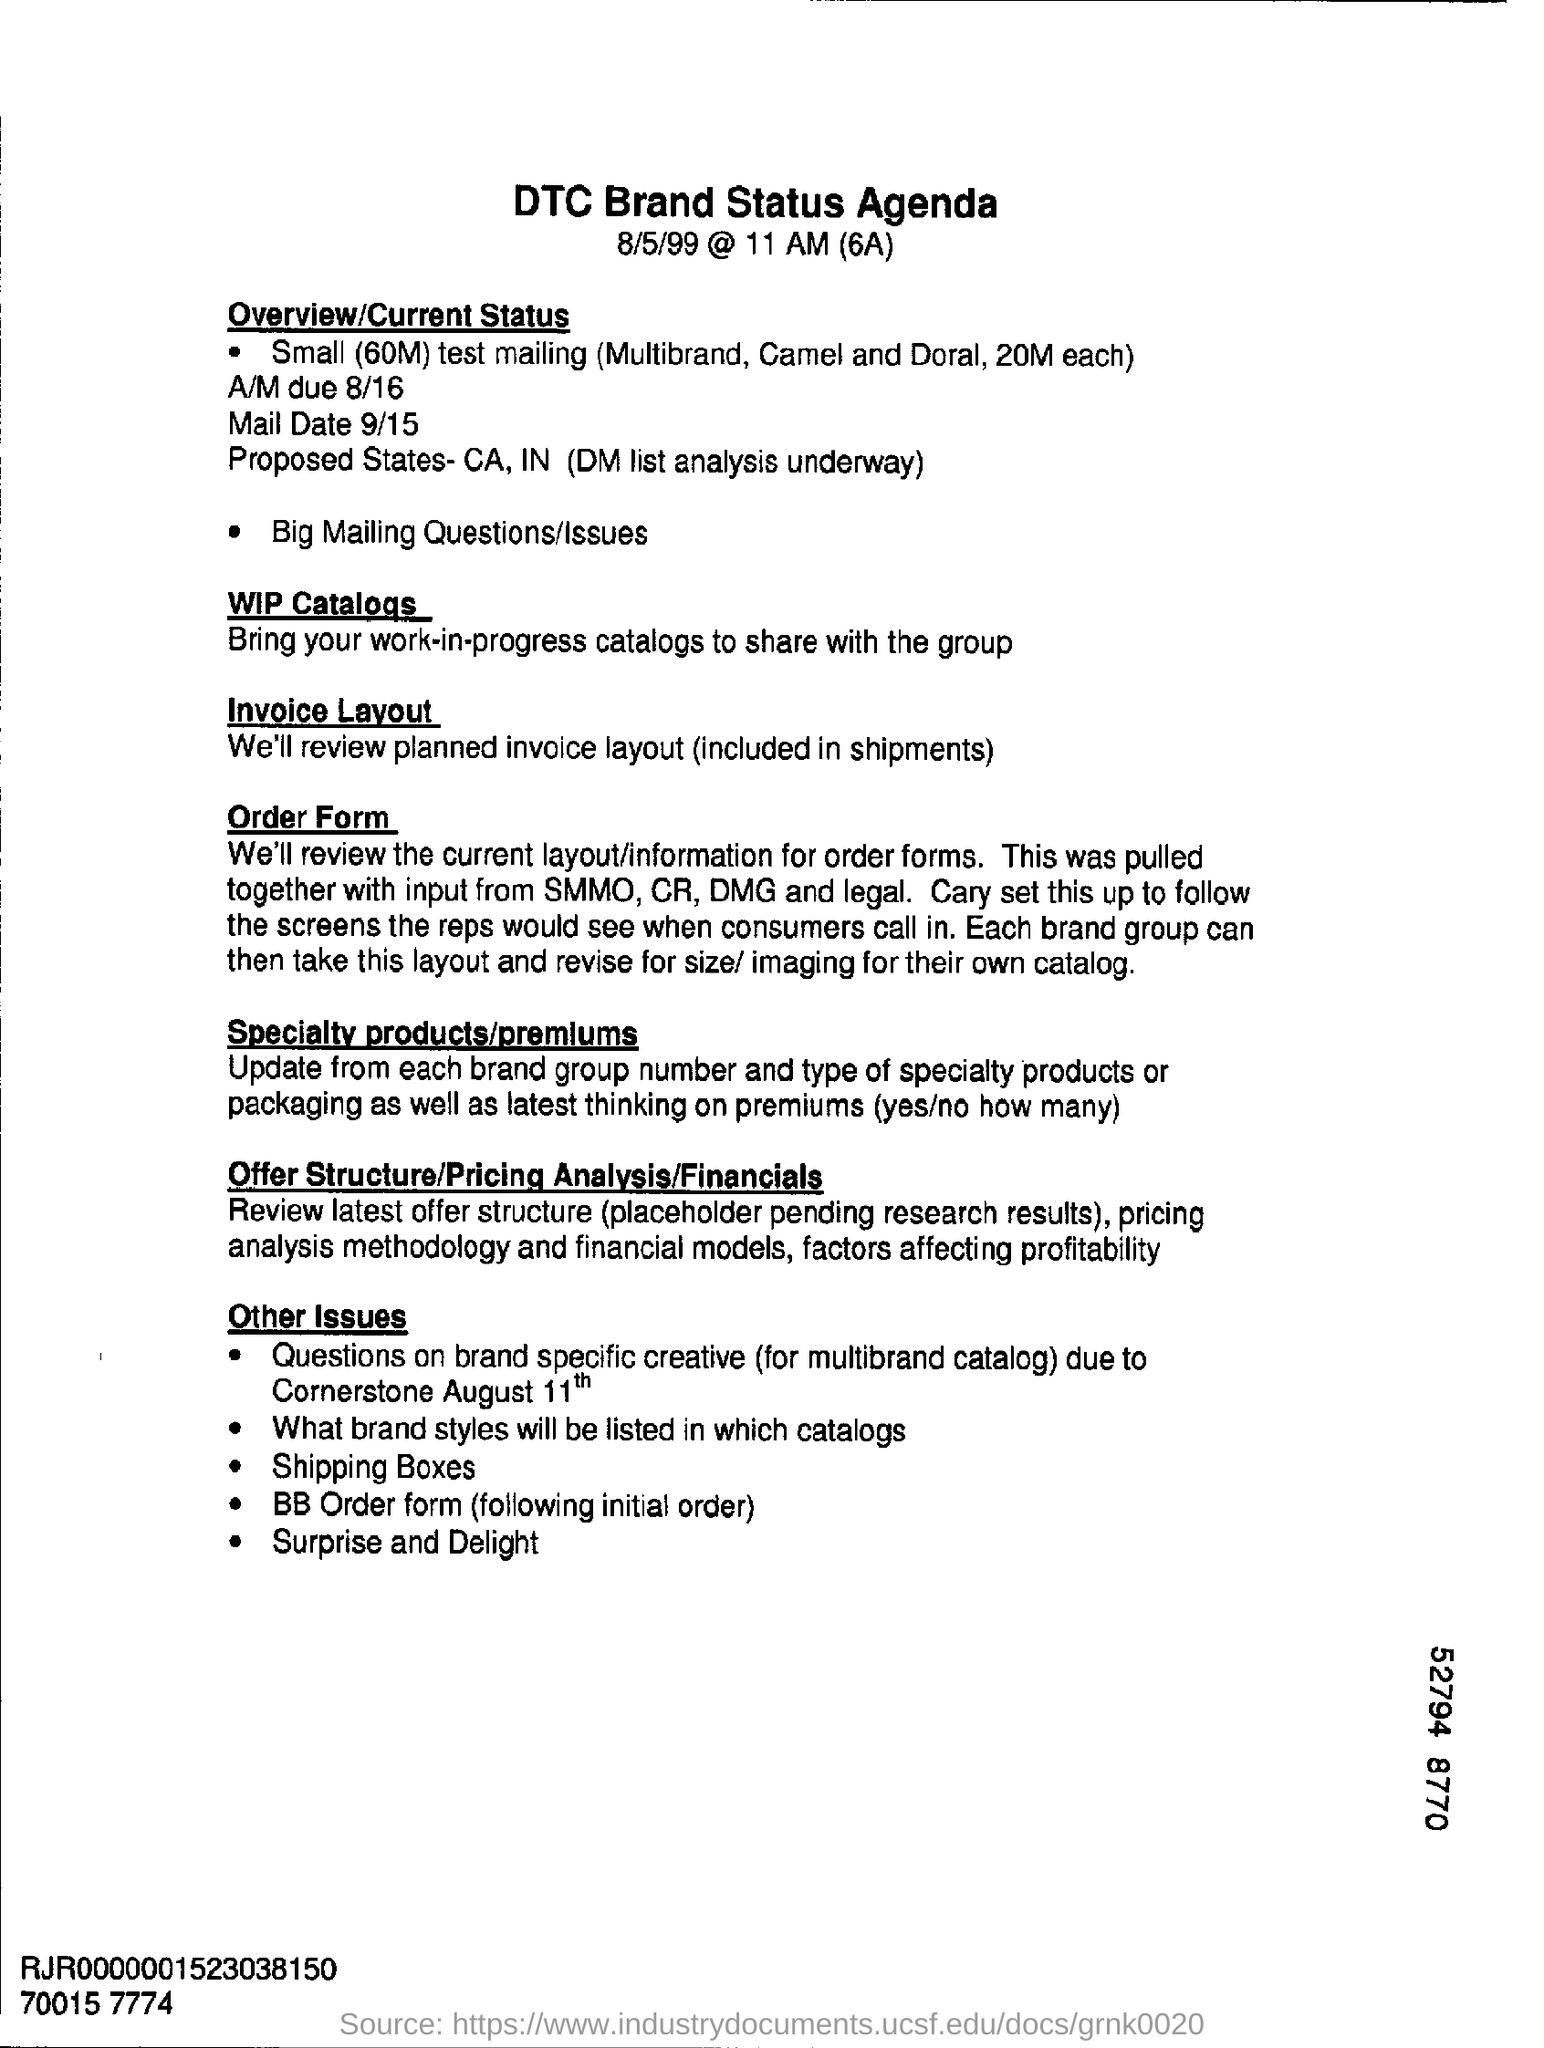How was current layout for order forms pulled together?
Make the answer very short. With input from smmo, cr, dmg and legal. What is the document about?
Give a very brief answer. DTC Brand Status Agenda. 